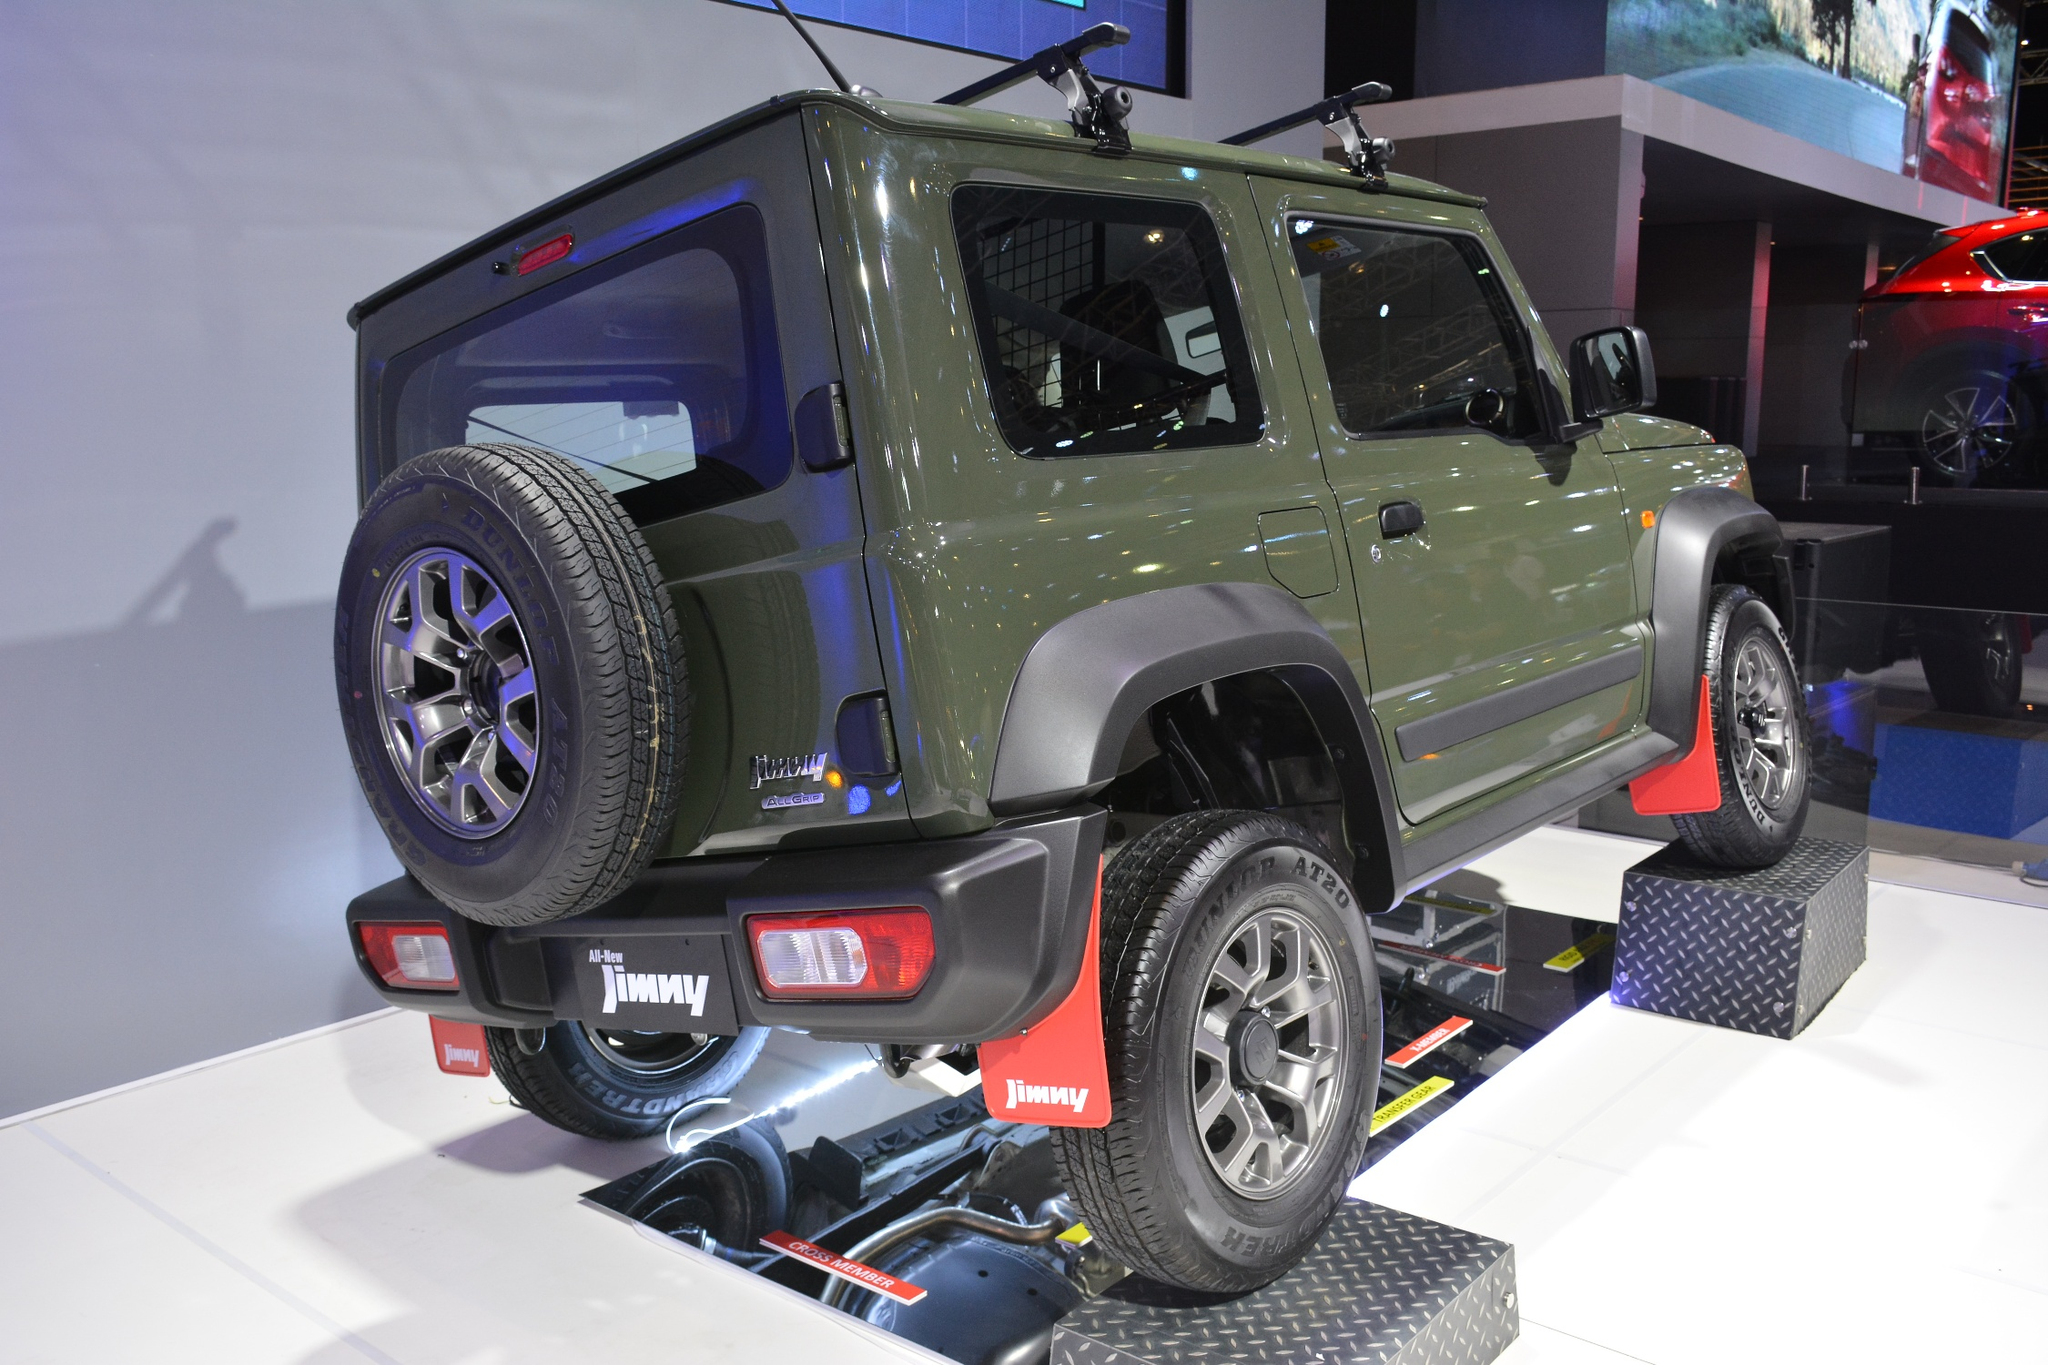What can you tell me about the general atmosphere of the car show? The general atmosphere of the car show depicted in the image is vibrant and bustling. The array of vehicles in the background, albeit blurred, suggests a large gathering of automobile enthusiasts. The lighting is bright, highlighting the polished surfaces of the cars and creating an energetic ambiance. This kind of event is typically filled with excitement as car lovers gather to admire new models, latest technology, and innovative designs. The Suzuki Jimny, with its bold color and off-road features, is designed to capture attention amidst the crowd, embodying the passion for rugged, adventure-ready vehicles. Are there any other notable details about the surrounding vehicles? While the background vehicles are somewhat blurred, their reflective surfaces and sleek silhouettes indicate a variety of modern cars on display. This variety hints at the diversity of the car show, showcasing everything from compact sedans to larger SUVs. The large, illuminated screens and display banners above suggest that this car show features detailed presentations and possibly live demonstrations or unveilings, enhancing the spectators' experience and engagement. 